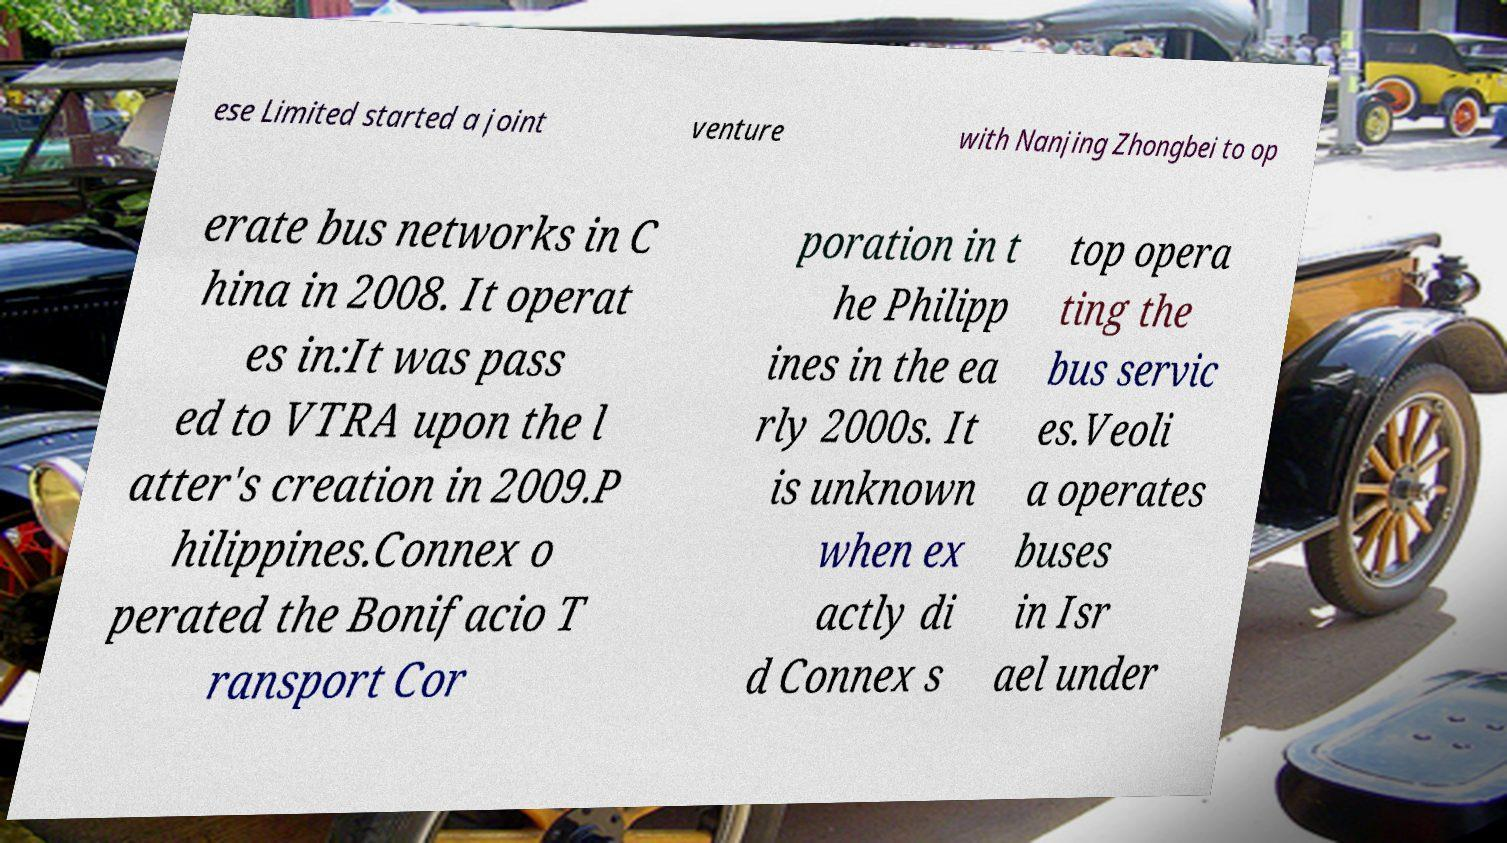Please identify and transcribe the text found in this image. ese Limited started a joint venture with Nanjing Zhongbei to op erate bus networks in C hina in 2008. It operat es in:It was pass ed to VTRA upon the l atter's creation in 2009.P hilippines.Connex o perated the Bonifacio T ransport Cor poration in t he Philipp ines in the ea rly 2000s. It is unknown when ex actly di d Connex s top opera ting the bus servic es.Veoli a operates buses in Isr ael under 